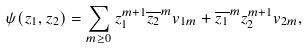<formula> <loc_0><loc_0><loc_500><loc_500>\psi ( z _ { 1 } , z _ { 2 } ) = \sum _ { m \geq 0 } z _ { 1 } ^ { m + 1 } \overline { z _ { 2 } } ^ { m } v _ { 1 m } + \overline { z _ { 1 } } ^ { m } z _ { 2 } ^ { m + 1 } v _ { 2 m } ,</formula> 